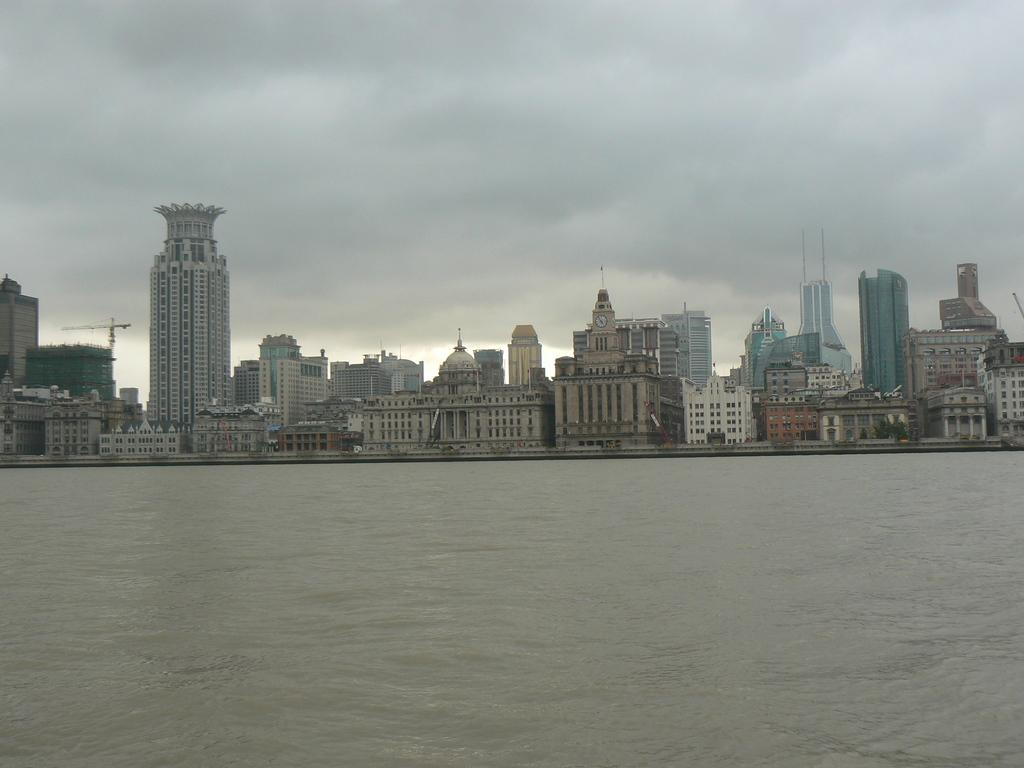What type of structures can be seen in the image? There are many buildings in the image. What other natural elements are present in the image? There are trees in the image. What type of machinery can be seen in the image? There is a crane in the image. What else can be seen in the image besides buildings, trees, and the crane? There are objects in the image. What is visible at the bottom of the image? There is water visible at the bottom of the image. How would you describe the sky in the background of the image? The sky is cloudy in the background of the image. What type of camp can be seen in the image? There is no camp present in the image. What emotion is being expressed by the objects in the image? The objects in the image do not express emotions, as they are inanimate. 